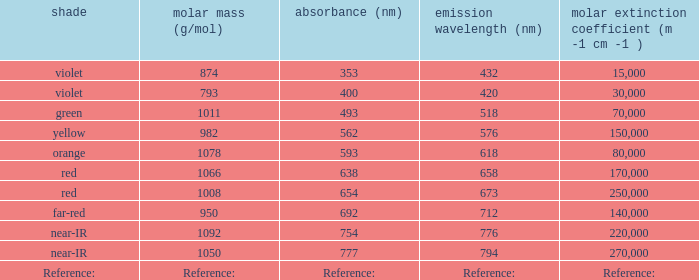What is the assimilation (in nanometers) of the orange hue? 593.0. 